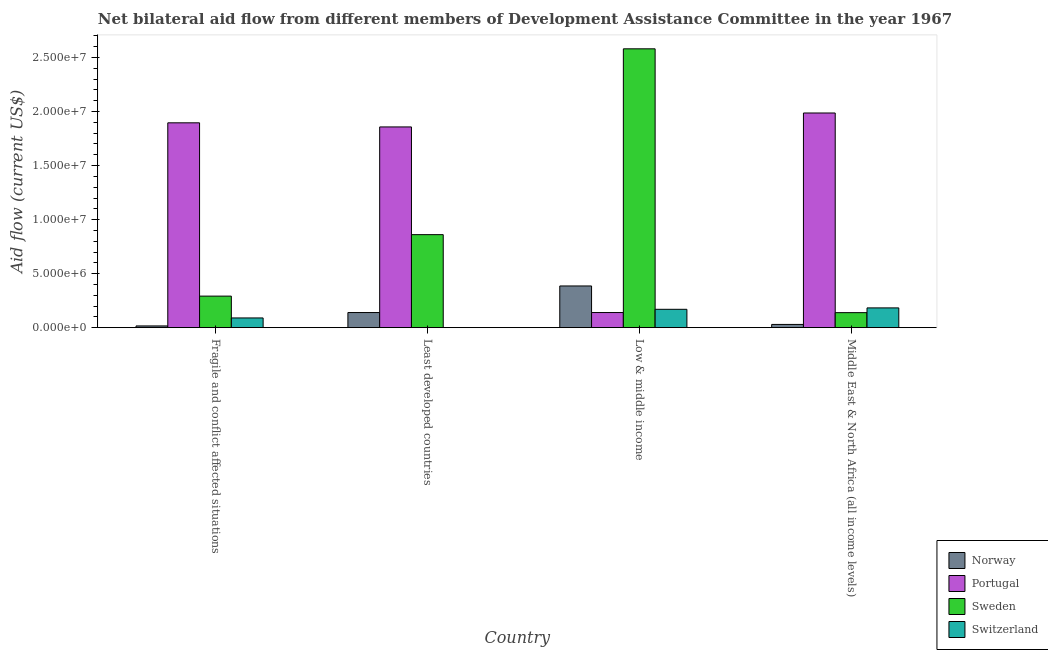How many groups of bars are there?
Keep it short and to the point. 4. How many bars are there on the 3rd tick from the right?
Offer a terse response. 3. In how many cases, is the number of bars for a given country not equal to the number of legend labels?
Make the answer very short. 1. What is the amount of aid given by sweden in Middle East & North Africa (all income levels)?
Your response must be concise. 1.39e+06. Across all countries, what is the maximum amount of aid given by portugal?
Keep it short and to the point. 1.99e+07. In which country was the amount of aid given by switzerland maximum?
Offer a terse response. Middle East & North Africa (all income levels). What is the total amount of aid given by norway in the graph?
Your response must be concise. 5.72e+06. What is the difference between the amount of aid given by sweden in Least developed countries and that in Middle East & North Africa (all income levels)?
Provide a short and direct response. 7.22e+06. What is the difference between the amount of aid given by norway in Middle East & North Africa (all income levels) and the amount of aid given by sweden in Fragile and conflict affected situations?
Provide a succinct answer. -2.62e+06. What is the average amount of aid given by norway per country?
Offer a very short reply. 1.43e+06. What is the difference between the amount of aid given by portugal and amount of aid given by switzerland in Fragile and conflict affected situations?
Ensure brevity in your answer.  1.81e+07. What is the ratio of the amount of aid given by switzerland in Fragile and conflict affected situations to that in Middle East & North Africa (all income levels)?
Provide a short and direct response. 0.49. Is the amount of aid given by norway in Least developed countries less than that in Low & middle income?
Keep it short and to the point. Yes. Is the difference between the amount of aid given by portugal in Least developed countries and Low & middle income greater than the difference between the amount of aid given by norway in Least developed countries and Low & middle income?
Your answer should be very brief. Yes. What is the difference between the highest and the second highest amount of aid given by portugal?
Your response must be concise. 9.10e+05. What is the difference between the highest and the lowest amount of aid given by switzerland?
Offer a terse response. 1.83e+06. In how many countries, is the amount of aid given by portugal greater than the average amount of aid given by portugal taken over all countries?
Your answer should be compact. 3. Is the sum of the amount of aid given by norway in Fragile and conflict affected situations and Middle East & North Africa (all income levels) greater than the maximum amount of aid given by portugal across all countries?
Offer a very short reply. No. Is it the case that in every country, the sum of the amount of aid given by portugal and amount of aid given by norway is greater than the sum of amount of aid given by switzerland and amount of aid given by sweden?
Offer a terse response. No. What is the difference between two consecutive major ticks on the Y-axis?
Your answer should be very brief. 5.00e+06. Does the graph contain any zero values?
Ensure brevity in your answer.  Yes. How many legend labels are there?
Offer a very short reply. 4. What is the title of the graph?
Your answer should be compact. Net bilateral aid flow from different members of Development Assistance Committee in the year 1967. Does "PFC gas" appear as one of the legend labels in the graph?
Make the answer very short. No. What is the label or title of the X-axis?
Your answer should be compact. Country. What is the Aid flow (current US$) in Norway in Fragile and conflict affected situations?
Ensure brevity in your answer.  1.60e+05. What is the Aid flow (current US$) of Portugal in Fragile and conflict affected situations?
Give a very brief answer. 1.90e+07. What is the Aid flow (current US$) of Sweden in Fragile and conflict affected situations?
Provide a short and direct response. 2.92e+06. What is the Aid flow (current US$) in Switzerland in Fragile and conflict affected situations?
Provide a succinct answer. 9.00e+05. What is the Aid flow (current US$) in Norway in Least developed countries?
Keep it short and to the point. 1.40e+06. What is the Aid flow (current US$) of Portugal in Least developed countries?
Your answer should be compact. 1.86e+07. What is the Aid flow (current US$) in Sweden in Least developed countries?
Offer a terse response. 8.61e+06. What is the Aid flow (current US$) of Norway in Low & middle income?
Your answer should be very brief. 3.86e+06. What is the Aid flow (current US$) of Portugal in Low & middle income?
Provide a short and direct response. 1.40e+06. What is the Aid flow (current US$) of Sweden in Low & middle income?
Provide a succinct answer. 2.58e+07. What is the Aid flow (current US$) in Switzerland in Low & middle income?
Offer a terse response. 1.70e+06. What is the Aid flow (current US$) of Norway in Middle East & North Africa (all income levels)?
Keep it short and to the point. 3.00e+05. What is the Aid flow (current US$) of Portugal in Middle East & North Africa (all income levels)?
Your answer should be compact. 1.99e+07. What is the Aid flow (current US$) of Sweden in Middle East & North Africa (all income levels)?
Ensure brevity in your answer.  1.39e+06. What is the Aid flow (current US$) in Switzerland in Middle East & North Africa (all income levels)?
Offer a very short reply. 1.83e+06. Across all countries, what is the maximum Aid flow (current US$) in Norway?
Give a very brief answer. 3.86e+06. Across all countries, what is the maximum Aid flow (current US$) of Portugal?
Keep it short and to the point. 1.99e+07. Across all countries, what is the maximum Aid flow (current US$) in Sweden?
Keep it short and to the point. 2.58e+07. Across all countries, what is the maximum Aid flow (current US$) of Switzerland?
Offer a very short reply. 1.83e+06. Across all countries, what is the minimum Aid flow (current US$) of Norway?
Your answer should be very brief. 1.60e+05. Across all countries, what is the minimum Aid flow (current US$) of Portugal?
Provide a succinct answer. 1.40e+06. Across all countries, what is the minimum Aid flow (current US$) in Sweden?
Your answer should be compact. 1.39e+06. What is the total Aid flow (current US$) of Norway in the graph?
Offer a very short reply. 5.72e+06. What is the total Aid flow (current US$) of Portugal in the graph?
Offer a very short reply. 5.88e+07. What is the total Aid flow (current US$) of Sweden in the graph?
Your answer should be very brief. 3.87e+07. What is the total Aid flow (current US$) of Switzerland in the graph?
Make the answer very short. 4.43e+06. What is the difference between the Aid flow (current US$) of Norway in Fragile and conflict affected situations and that in Least developed countries?
Your response must be concise. -1.24e+06. What is the difference between the Aid flow (current US$) of Portugal in Fragile and conflict affected situations and that in Least developed countries?
Provide a short and direct response. 3.80e+05. What is the difference between the Aid flow (current US$) in Sweden in Fragile and conflict affected situations and that in Least developed countries?
Provide a short and direct response. -5.69e+06. What is the difference between the Aid flow (current US$) of Norway in Fragile and conflict affected situations and that in Low & middle income?
Your response must be concise. -3.70e+06. What is the difference between the Aid flow (current US$) of Portugal in Fragile and conflict affected situations and that in Low & middle income?
Make the answer very short. 1.76e+07. What is the difference between the Aid flow (current US$) of Sweden in Fragile and conflict affected situations and that in Low & middle income?
Your answer should be compact. -2.29e+07. What is the difference between the Aid flow (current US$) in Switzerland in Fragile and conflict affected situations and that in Low & middle income?
Make the answer very short. -8.00e+05. What is the difference between the Aid flow (current US$) in Norway in Fragile and conflict affected situations and that in Middle East & North Africa (all income levels)?
Provide a short and direct response. -1.40e+05. What is the difference between the Aid flow (current US$) in Portugal in Fragile and conflict affected situations and that in Middle East & North Africa (all income levels)?
Your answer should be very brief. -9.10e+05. What is the difference between the Aid flow (current US$) of Sweden in Fragile and conflict affected situations and that in Middle East & North Africa (all income levels)?
Provide a short and direct response. 1.53e+06. What is the difference between the Aid flow (current US$) in Switzerland in Fragile and conflict affected situations and that in Middle East & North Africa (all income levels)?
Keep it short and to the point. -9.30e+05. What is the difference between the Aid flow (current US$) of Norway in Least developed countries and that in Low & middle income?
Provide a short and direct response. -2.46e+06. What is the difference between the Aid flow (current US$) of Portugal in Least developed countries and that in Low & middle income?
Ensure brevity in your answer.  1.72e+07. What is the difference between the Aid flow (current US$) of Sweden in Least developed countries and that in Low & middle income?
Make the answer very short. -1.72e+07. What is the difference between the Aid flow (current US$) in Norway in Least developed countries and that in Middle East & North Africa (all income levels)?
Give a very brief answer. 1.10e+06. What is the difference between the Aid flow (current US$) in Portugal in Least developed countries and that in Middle East & North Africa (all income levels)?
Your answer should be very brief. -1.29e+06. What is the difference between the Aid flow (current US$) in Sweden in Least developed countries and that in Middle East & North Africa (all income levels)?
Provide a short and direct response. 7.22e+06. What is the difference between the Aid flow (current US$) in Norway in Low & middle income and that in Middle East & North Africa (all income levels)?
Ensure brevity in your answer.  3.56e+06. What is the difference between the Aid flow (current US$) of Portugal in Low & middle income and that in Middle East & North Africa (all income levels)?
Your answer should be compact. -1.85e+07. What is the difference between the Aid flow (current US$) in Sweden in Low & middle income and that in Middle East & North Africa (all income levels)?
Make the answer very short. 2.44e+07. What is the difference between the Aid flow (current US$) of Switzerland in Low & middle income and that in Middle East & North Africa (all income levels)?
Offer a very short reply. -1.30e+05. What is the difference between the Aid flow (current US$) in Norway in Fragile and conflict affected situations and the Aid flow (current US$) in Portugal in Least developed countries?
Keep it short and to the point. -1.84e+07. What is the difference between the Aid flow (current US$) in Norway in Fragile and conflict affected situations and the Aid flow (current US$) in Sweden in Least developed countries?
Ensure brevity in your answer.  -8.45e+06. What is the difference between the Aid flow (current US$) in Portugal in Fragile and conflict affected situations and the Aid flow (current US$) in Sweden in Least developed countries?
Give a very brief answer. 1.04e+07. What is the difference between the Aid flow (current US$) of Norway in Fragile and conflict affected situations and the Aid flow (current US$) of Portugal in Low & middle income?
Make the answer very short. -1.24e+06. What is the difference between the Aid flow (current US$) of Norway in Fragile and conflict affected situations and the Aid flow (current US$) of Sweden in Low & middle income?
Your answer should be very brief. -2.56e+07. What is the difference between the Aid flow (current US$) of Norway in Fragile and conflict affected situations and the Aid flow (current US$) of Switzerland in Low & middle income?
Provide a short and direct response. -1.54e+06. What is the difference between the Aid flow (current US$) of Portugal in Fragile and conflict affected situations and the Aid flow (current US$) of Sweden in Low & middle income?
Your answer should be very brief. -6.85e+06. What is the difference between the Aid flow (current US$) in Portugal in Fragile and conflict affected situations and the Aid flow (current US$) in Switzerland in Low & middle income?
Keep it short and to the point. 1.73e+07. What is the difference between the Aid flow (current US$) of Sweden in Fragile and conflict affected situations and the Aid flow (current US$) of Switzerland in Low & middle income?
Offer a terse response. 1.22e+06. What is the difference between the Aid flow (current US$) in Norway in Fragile and conflict affected situations and the Aid flow (current US$) in Portugal in Middle East & North Africa (all income levels)?
Offer a terse response. -1.97e+07. What is the difference between the Aid flow (current US$) in Norway in Fragile and conflict affected situations and the Aid flow (current US$) in Sweden in Middle East & North Africa (all income levels)?
Provide a succinct answer. -1.23e+06. What is the difference between the Aid flow (current US$) in Norway in Fragile and conflict affected situations and the Aid flow (current US$) in Switzerland in Middle East & North Africa (all income levels)?
Offer a terse response. -1.67e+06. What is the difference between the Aid flow (current US$) in Portugal in Fragile and conflict affected situations and the Aid flow (current US$) in Sweden in Middle East & North Africa (all income levels)?
Offer a terse response. 1.76e+07. What is the difference between the Aid flow (current US$) of Portugal in Fragile and conflict affected situations and the Aid flow (current US$) of Switzerland in Middle East & North Africa (all income levels)?
Your answer should be compact. 1.71e+07. What is the difference between the Aid flow (current US$) of Sweden in Fragile and conflict affected situations and the Aid flow (current US$) of Switzerland in Middle East & North Africa (all income levels)?
Provide a short and direct response. 1.09e+06. What is the difference between the Aid flow (current US$) in Norway in Least developed countries and the Aid flow (current US$) in Portugal in Low & middle income?
Provide a succinct answer. 0. What is the difference between the Aid flow (current US$) of Norway in Least developed countries and the Aid flow (current US$) of Sweden in Low & middle income?
Ensure brevity in your answer.  -2.44e+07. What is the difference between the Aid flow (current US$) in Norway in Least developed countries and the Aid flow (current US$) in Switzerland in Low & middle income?
Provide a short and direct response. -3.00e+05. What is the difference between the Aid flow (current US$) of Portugal in Least developed countries and the Aid flow (current US$) of Sweden in Low & middle income?
Your response must be concise. -7.23e+06. What is the difference between the Aid flow (current US$) of Portugal in Least developed countries and the Aid flow (current US$) of Switzerland in Low & middle income?
Ensure brevity in your answer.  1.69e+07. What is the difference between the Aid flow (current US$) in Sweden in Least developed countries and the Aid flow (current US$) in Switzerland in Low & middle income?
Ensure brevity in your answer.  6.91e+06. What is the difference between the Aid flow (current US$) in Norway in Least developed countries and the Aid flow (current US$) in Portugal in Middle East & North Africa (all income levels)?
Make the answer very short. -1.85e+07. What is the difference between the Aid flow (current US$) of Norway in Least developed countries and the Aid flow (current US$) of Switzerland in Middle East & North Africa (all income levels)?
Your answer should be very brief. -4.30e+05. What is the difference between the Aid flow (current US$) in Portugal in Least developed countries and the Aid flow (current US$) in Sweden in Middle East & North Africa (all income levels)?
Give a very brief answer. 1.72e+07. What is the difference between the Aid flow (current US$) of Portugal in Least developed countries and the Aid flow (current US$) of Switzerland in Middle East & North Africa (all income levels)?
Give a very brief answer. 1.68e+07. What is the difference between the Aid flow (current US$) in Sweden in Least developed countries and the Aid flow (current US$) in Switzerland in Middle East & North Africa (all income levels)?
Offer a very short reply. 6.78e+06. What is the difference between the Aid flow (current US$) in Norway in Low & middle income and the Aid flow (current US$) in Portugal in Middle East & North Africa (all income levels)?
Your answer should be very brief. -1.60e+07. What is the difference between the Aid flow (current US$) in Norway in Low & middle income and the Aid flow (current US$) in Sweden in Middle East & North Africa (all income levels)?
Make the answer very short. 2.47e+06. What is the difference between the Aid flow (current US$) of Norway in Low & middle income and the Aid flow (current US$) of Switzerland in Middle East & North Africa (all income levels)?
Your answer should be very brief. 2.03e+06. What is the difference between the Aid flow (current US$) of Portugal in Low & middle income and the Aid flow (current US$) of Sweden in Middle East & North Africa (all income levels)?
Provide a short and direct response. 10000. What is the difference between the Aid flow (current US$) in Portugal in Low & middle income and the Aid flow (current US$) in Switzerland in Middle East & North Africa (all income levels)?
Ensure brevity in your answer.  -4.30e+05. What is the difference between the Aid flow (current US$) of Sweden in Low & middle income and the Aid flow (current US$) of Switzerland in Middle East & North Africa (all income levels)?
Your answer should be very brief. 2.40e+07. What is the average Aid flow (current US$) of Norway per country?
Keep it short and to the point. 1.43e+06. What is the average Aid flow (current US$) in Portugal per country?
Provide a succinct answer. 1.47e+07. What is the average Aid flow (current US$) in Sweden per country?
Provide a succinct answer. 9.68e+06. What is the average Aid flow (current US$) of Switzerland per country?
Provide a succinct answer. 1.11e+06. What is the difference between the Aid flow (current US$) of Norway and Aid flow (current US$) of Portugal in Fragile and conflict affected situations?
Ensure brevity in your answer.  -1.88e+07. What is the difference between the Aid flow (current US$) of Norway and Aid flow (current US$) of Sweden in Fragile and conflict affected situations?
Keep it short and to the point. -2.76e+06. What is the difference between the Aid flow (current US$) in Norway and Aid flow (current US$) in Switzerland in Fragile and conflict affected situations?
Offer a very short reply. -7.40e+05. What is the difference between the Aid flow (current US$) in Portugal and Aid flow (current US$) in Sweden in Fragile and conflict affected situations?
Make the answer very short. 1.60e+07. What is the difference between the Aid flow (current US$) of Portugal and Aid flow (current US$) of Switzerland in Fragile and conflict affected situations?
Your answer should be compact. 1.81e+07. What is the difference between the Aid flow (current US$) of Sweden and Aid flow (current US$) of Switzerland in Fragile and conflict affected situations?
Keep it short and to the point. 2.02e+06. What is the difference between the Aid flow (current US$) in Norway and Aid flow (current US$) in Portugal in Least developed countries?
Offer a very short reply. -1.72e+07. What is the difference between the Aid flow (current US$) in Norway and Aid flow (current US$) in Sweden in Least developed countries?
Your response must be concise. -7.21e+06. What is the difference between the Aid flow (current US$) in Portugal and Aid flow (current US$) in Sweden in Least developed countries?
Ensure brevity in your answer.  9.97e+06. What is the difference between the Aid flow (current US$) of Norway and Aid flow (current US$) of Portugal in Low & middle income?
Give a very brief answer. 2.46e+06. What is the difference between the Aid flow (current US$) of Norway and Aid flow (current US$) of Sweden in Low & middle income?
Make the answer very short. -2.20e+07. What is the difference between the Aid flow (current US$) of Norway and Aid flow (current US$) of Switzerland in Low & middle income?
Your answer should be very brief. 2.16e+06. What is the difference between the Aid flow (current US$) in Portugal and Aid flow (current US$) in Sweden in Low & middle income?
Provide a succinct answer. -2.44e+07. What is the difference between the Aid flow (current US$) of Portugal and Aid flow (current US$) of Switzerland in Low & middle income?
Ensure brevity in your answer.  -3.00e+05. What is the difference between the Aid flow (current US$) in Sweden and Aid flow (current US$) in Switzerland in Low & middle income?
Give a very brief answer. 2.41e+07. What is the difference between the Aid flow (current US$) in Norway and Aid flow (current US$) in Portugal in Middle East & North Africa (all income levels)?
Offer a very short reply. -1.96e+07. What is the difference between the Aid flow (current US$) of Norway and Aid flow (current US$) of Sweden in Middle East & North Africa (all income levels)?
Give a very brief answer. -1.09e+06. What is the difference between the Aid flow (current US$) in Norway and Aid flow (current US$) in Switzerland in Middle East & North Africa (all income levels)?
Your answer should be compact. -1.53e+06. What is the difference between the Aid flow (current US$) of Portugal and Aid flow (current US$) of Sweden in Middle East & North Africa (all income levels)?
Keep it short and to the point. 1.85e+07. What is the difference between the Aid flow (current US$) of Portugal and Aid flow (current US$) of Switzerland in Middle East & North Africa (all income levels)?
Offer a terse response. 1.80e+07. What is the difference between the Aid flow (current US$) in Sweden and Aid flow (current US$) in Switzerland in Middle East & North Africa (all income levels)?
Offer a very short reply. -4.40e+05. What is the ratio of the Aid flow (current US$) of Norway in Fragile and conflict affected situations to that in Least developed countries?
Your answer should be very brief. 0.11. What is the ratio of the Aid flow (current US$) of Portugal in Fragile and conflict affected situations to that in Least developed countries?
Your answer should be very brief. 1.02. What is the ratio of the Aid flow (current US$) in Sweden in Fragile and conflict affected situations to that in Least developed countries?
Provide a short and direct response. 0.34. What is the ratio of the Aid flow (current US$) of Norway in Fragile and conflict affected situations to that in Low & middle income?
Keep it short and to the point. 0.04. What is the ratio of the Aid flow (current US$) of Portugal in Fragile and conflict affected situations to that in Low & middle income?
Offer a terse response. 13.54. What is the ratio of the Aid flow (current US$) of Sweden in Fragile and conflict affected situations to that in Low & middle income?
Give a very brief answer. 0.11. What is the ratio of the Aid flow (current US$) of Switzerland in Fragile and conflict affected situations to that in Low & middle income?
Provide a succinct answer. 0.53. What is the ratio of the Aid flow (current US$) in Norway in Fragile and conflict affected situations to that in Middle East & North Africa (all income levels)?
Provide a short and direct response. 0.53. What is the ratio of the Aid flow (current US$) of Portugal in Fragile and conflict affected situations to that in Middle East & North Africa (all income levels)?
Offer a very short reply. 0.95. What is the ratio of the Aid flow (current US$) in Sweden in Fragile and conflict affected situations to that in Middle East & North Africa (all income levels)?
Make the answer very short. 2.1. What is the ratio of the Aid flow (current US$) of Switzerland in Fragile and conflict affected situations to that in Middle East & North Africa (all income levels)?
Your answer should be very brief. 0.49. What is the ratio of the Aid flow (current US$) of Norway in Least developed countries to that in Low & middle income?
Provide a short and direct response. 0.36. What is the ratio of the Aid flow (current US$) of Portugal in Least developed countries to that in Low & middle income?
Offer a terse response. 13.27. What is the ratio of the Aid flow (current US$) of Sweden in Least developed countries to that in Low & middle income?
Provide a short and direct response. 0.33. What is the ratio of the Aid flow (current US$) in Norway in Least developed countries to that in Middle East & North Africa (all income levels)?
Offer a terse response. 4.67. What is the ratio of the Aid flow (current US$) of Portugal in Least developed countries to that in Middle East & North Africa (all income levels)?
Make the answer very short. 0.94. What is the ratio of the Aid flow (current US$) in Sweden in Least developed countries to that in Middle East & North Africa (all income levels)?
Your response must be concise. 6.19. What is the ratio of the Aid flow (current US$) in Norway in Low & middle income to that in Middle East & North Africa (all income levels)?
Your answer should be very brief. 12.87. What is the ratio of the Aid flow (current US$) of Portugal in Low & middle income to that in Middle East & North Africa (all income levels)?
Ensure brevity in your answer.  0.07. What is the ratio of the Aid flow (current US$) of Sweden in Low & middle income to that in Middle East & North Africa (all income levels)?
Ensure brevity in your answer.  18.57. What is the ratio of the Aid flow (current US$) in Switzerland in Low & middle income to that in Middle East & North Africa (all income levels)?
Offer a terse response. 0.93. What is the difference between the highest and the second highest Aid flow (current US$) in Norway?
Your response must be concise. 2.46e+06. What is the difference between the highest and the second highest Aid flow (current US$) in Portugal?
Offer a terse response. 9.10e+05. What is the difference between the highest and the second highest Aid flow (current US$) of Sweden?
Provide a succinct answer. 1.72e+07. What is the difference between the highest and the lowest Aid flow (current US$) of Norway?
Offer a very short reply. 3.70e+06. What is the difference between the highest and the lowest Aid flow (current US$) of Portugal?
Provide a short and direct response. 1.85e+07. What is the difference between the highest and the lowest Aid flow (current US$) of Sweden?
Make the answer very short. 2.44e+07. What is the difference between the highest and the lowest Aid flow (current US$) in Switzerland?
Ensure brevity in your answer.  1.83e+06. 